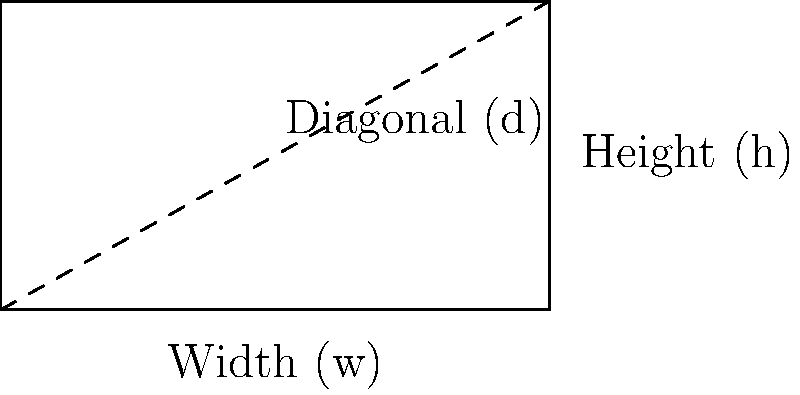As a filmmaker preparing to shoot your next project, you're considering a widescreen format with a 16:9 aspect ratio. If you have a screen with a diagonal measurement of 55 inches, what are the width and height of the screen in inches? Round your answer to the nearest tenth of an inch. To solve this problem, we'll use the Pythagorean theorem and the aspect ratio. Let's break it down step-by-step:

1) The aspect ratio is 16:9, so we can express the width (w) and height (h) as:
   $w = 16x$ and $h = 9x$, where $x$ is some scaling factor.

2) We know the diagonal (d) is 55 inches. Using the Pythagorean theorem:
   $d^2 = w^2 + h^2$

3) Substituting our expressions for w and h:
   $55^2 = (16x)^2 + (9x)^2$

4) Simplify:
   $3025 = 256x^2 + 81x^2 = 337x^2$

5) Solve for x:
   $x^2 = 3025 / 337$
   $x = \sqrt{3025 / 337} \approx 2.997$

6) Now we can calculate w and h:
   $w = 16x = 16 * 2.997 \approx 47.95$ inches
   $h = 9x = 9 * 2.997 \approx 26.97$ inches

7) Rounding to the nearest tenth:
   Width ≈ 48.0 inches
   Height ≈ 27.0 inches
Answer: Width: 48.0 inches, Height: 27.0 inches 